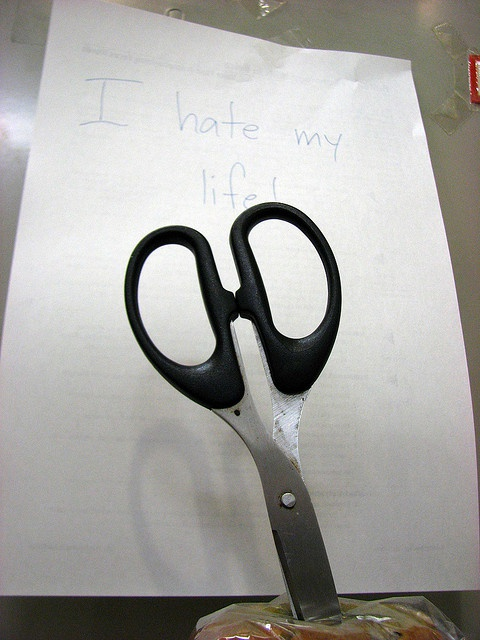Describe the objects in this image and their specific colors. I can see scissors in gray, black, lightgray, and darkgray tones in this image. 